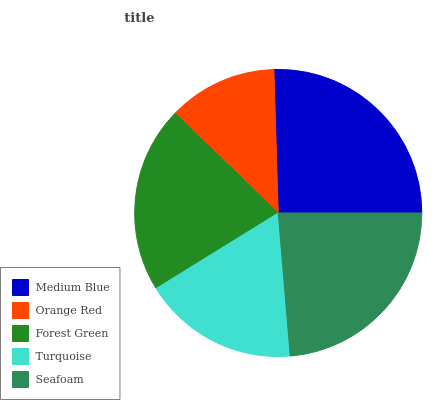Is Orange Red the minimum?
Answer yes or no. Yes. Is Medium Blue the maximum?
Answer yes or no. Yes. Is Forest Green the minimum?
Answer yes or no. No. Is Forest Green the maximum?
Answer yes or no. No. Is Forest Green greater than Orange Red?
Answer yes or no. Yes. Is Orange Red less than Forest Green?
Answer yes or no. Yes. Is Orange Red greater than Forest Green?
Answer yes or no. No. Is Forest Green less than Orange Red?
Answer yes or no. No. Is Forest Green the high median?
Answer yes or no. Yes. Is Forest Green the low median?
Answer yes or no. Yes. Is Orange Red the high median?
Answer yes or no. No. Is Medium Blue the low median?
Answer yes or no. No. 